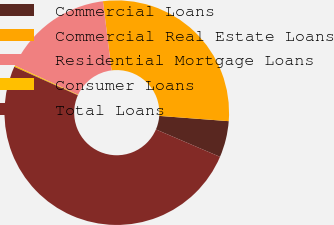Convert chart. <chart><loc_0><loc_0><loc_500><loc_500><pie_chart><fcel>Commercial Loans<fcel>Commercial Real Estate Loans<fcel>Residential Mortgage Loans<fcel>Consumer Loans<fcel>Total Loans<nl><fcel>5.23%<fcel>28.17%<fcel>16.15%<fcel>0.19%<fcel>50.26%<nl></chart> 